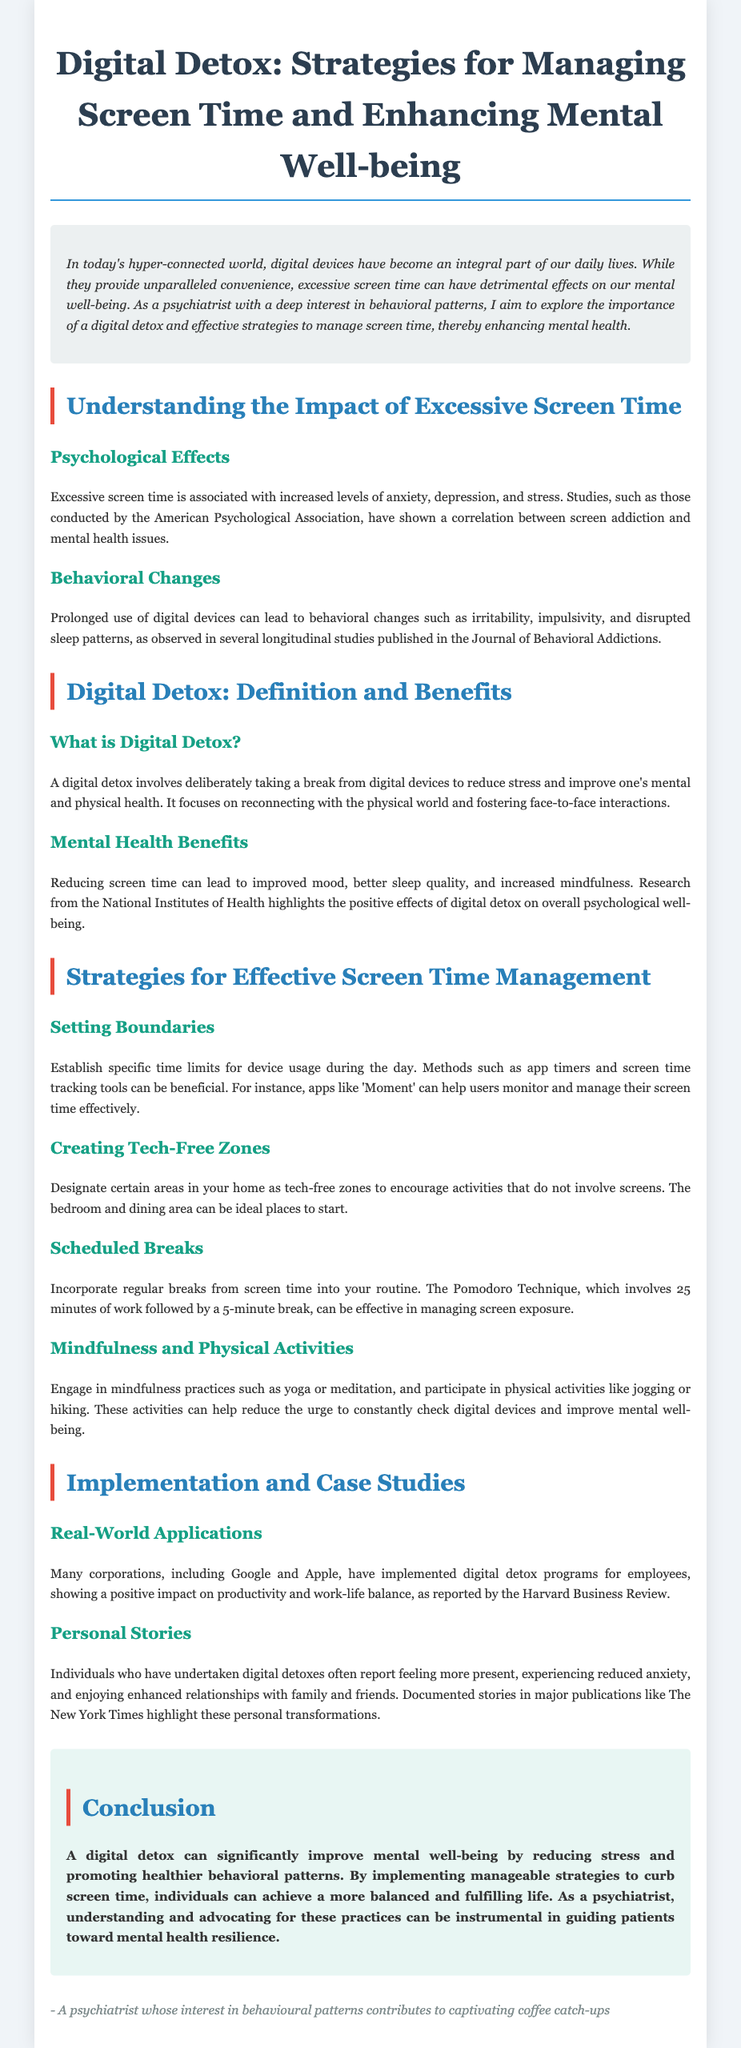What are the psychological effects of excessive screen time? The document lists increased levels of anxiety, depression, and stress as psychological effects of excessive screen time.
Answer: Anxiety, depression, stress What does a digital detox aim to improve? The document states that a digital detox aims to reduce stress and improve mental and physical health.
Answer: Mental and physical health Which app is mentioned for managing screen time? 'Moment' is cited as an app that helps track and manage screen time effectively.
Answer: Moment What technique involves 25 minutes of work followed by a 5-minute break? The Pomodoro Technique is mentioned as a method for taking regular breaks from screen time.
Answer: Pomodoro Technique What are the benefits of reducing screen time according to the document? Improved mood, better sleep quality, and increased mindfulness are benefits highlighted in the document.
Answer: Improved mood, better sleep quality, increased mindfulness What is designated as a tech-free zone? The document suggests areas such as the bedroom and dining area as ideal places to designate as tech-free zones.
Answer: Bedroom, dining area Which corporations implemented digital detox programs? Google and Apple are mentioned as corporations that have implemented digital detox programs for employees.
Answer: Google, Apple What is a noted benefit of personal digital detox stories? Individuals report feeling more present and experiencing reduced anxiety as benefits of personal digital detoxes.
Answer: Reduced anxiety What does the document suggest for engaging with physical activities? The document recommends participating in physical activities like jogging or hiking to help reduce the urge to check digital devices.
Answer: Jogging, hiking 